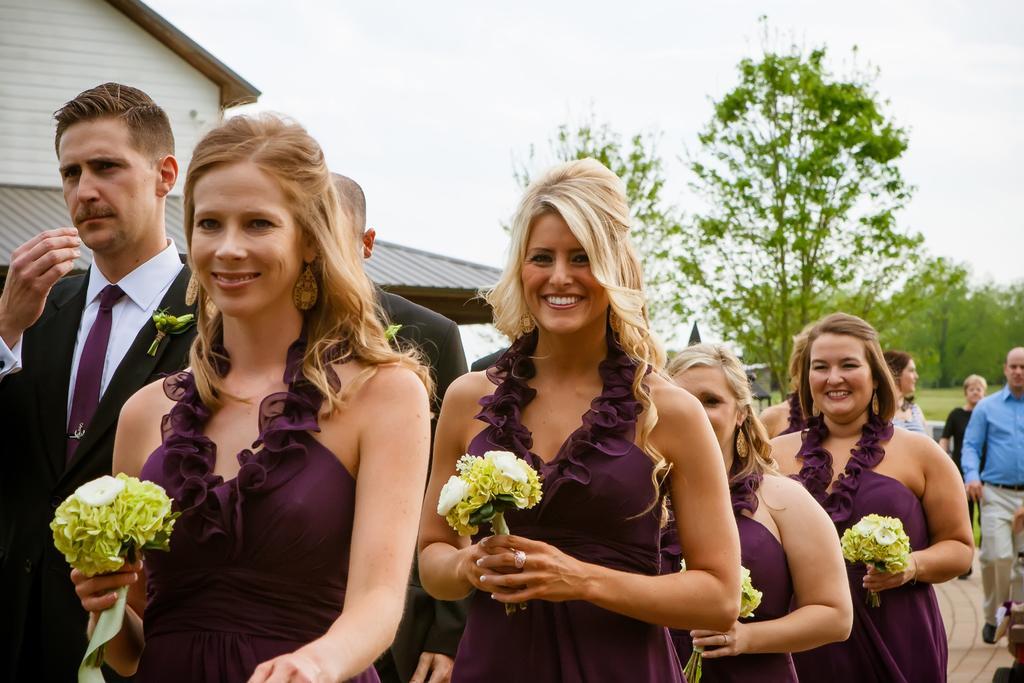How would you summarize this image in a sentence or two? In this image we can see the woman holding the flowers and smiling. We can also see the men. In the background we can see the trees, people, house and also the sky. We can also see the path. 